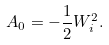Convert formula to latex. <formula><loc_0><loc_0><loc_500><loc_500>A _ { 0 } = - \frac { 1 } { 2 } W ^ { 2 } _ { i } .</formula> 